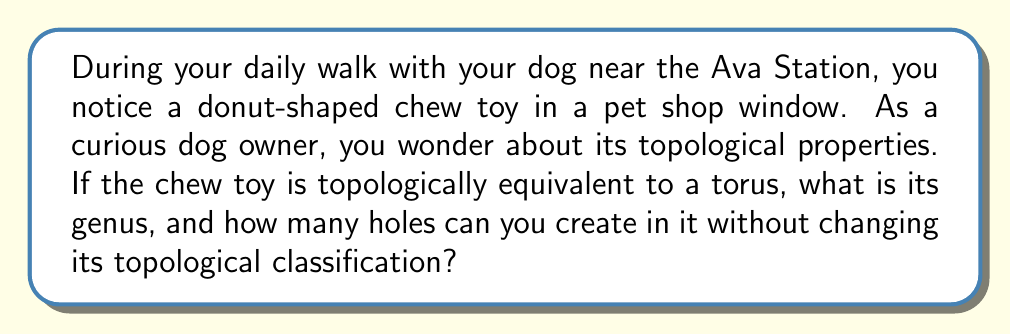Can you answer this question? To answer this question, we need to understand the concept of genus in topology and the properties of a torus:

1. Genus: The genus of a surface is the maximum number of non-intersecting simple closed curves that can be drawn on the surface without separating it into distinct regions. It can also be thought of as the number of "handles" on the surface.

2. Torus: A torus is a surface of revolution generated by revolving a circle in three-dimensional space about an axis that is coplanar with the circle but does not intersect it. It resembles the shape of a donut.

The genus of a torus is 1. This can be visualized as follows:

[asy]
import three;

size(200);
currentprojection=perspective(6,3,2);

revolution r=revolution(Circle(c=(2,0),r=1,normal=Z),Z,0,360);
draw(surface(r),paleblue+opacity(.7));
draw(r);
draw(Circle(c=(2,0),r=1,normal=Y),red);
draw(Circle(c=(2,0),r=1,normal=X),green);
[/asy]

The red and green circles represent two non-intersecting simple closed curves that can be drawn on the torus without separating it. One goes around the "hole" of the donut, and the other goes around the body of the donut.

Now, let's consider how many holes we can create without changing its topological classification:

1. The torus already has one "hole" (the center of the donut).
2. We can create one additional hole through the body of the torus (from top to bottom or side to side) without changing its topological classification.
3. Creating any more holes would change its topological properties.

This is because creating one additional hole is equivalent to adding a "tunnel" through the torus, which doesn't change its genus. However, adding more holes would increase the genus or potentially separate the surface into distinct regions.

Therefore, we can create one additional hole (for a total of two holes) without changing the topological classification of the torus.
Answer: The genus of the donut-shaped chew toy (torus) is 1, and you can create 1 additional hole (for a total of 2 holes) without changing its topological classification. 